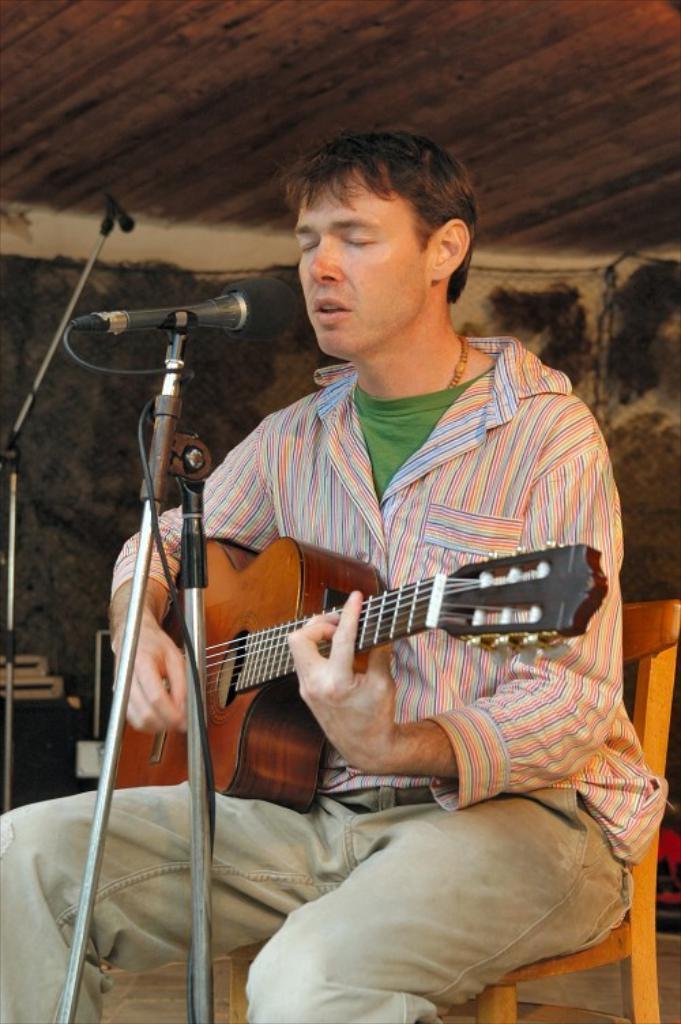Could you give a brief overview of what you see in this image? In this image there is a person sitting and playing guitar and he is singing. There is a microphone and at the back there is a box. 